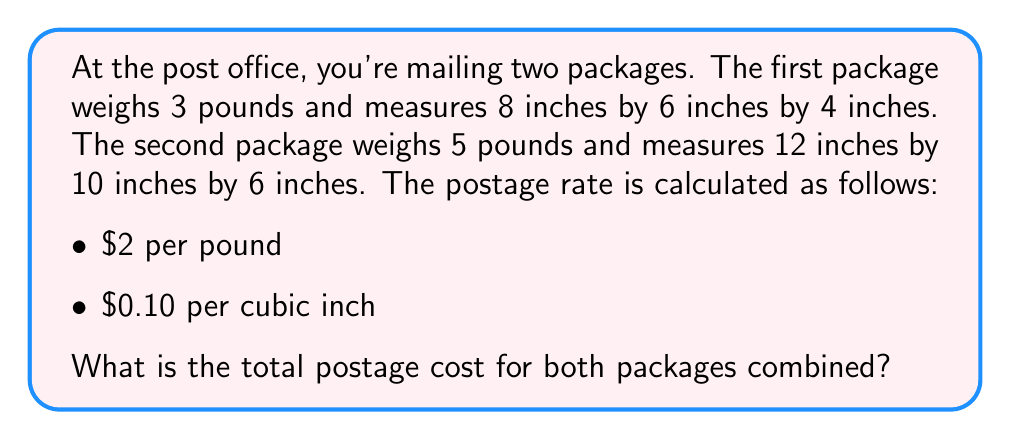Can you answer this question? Let's break this down step-by-step:

1. Calculate the volume of each package:
   Package 1: $V_1 = 8 \times 6 \times 4 = 192$ cubic inches
   Package 2: $V_2 = 12 \times 10 \times 6 = 720$ cubic inches

2. Calculate the weight-based cost:
   Package 1: $3 \text{ lbs} \times \$2/\text{lb} = \$6$
   Package 2: $5 \text{ lbs} \times \$2/\text{lb} = \$10$
   Total weight-based cost: $\$6 + \$10 = \$16$

3. Calculate the volume-based cost:
   Package 1: $192 \text{ in}^3 \times \$0.10/\text{in}^3 = \$19.20$
   Package 2: $720 \text{ in}^3 \times \$0.10/\text{in}^3 = \$72.00$
   Total volume-based cost: $\$19.20 + \$72.00 = \$91.20$

4. Sum up the total cost:
   Total cost = Weight-based cost + Volume-based cost
   $$ \text{Total cost} = \$16 + \$91.20 = \$107.20 $$
Answer: $107.20 